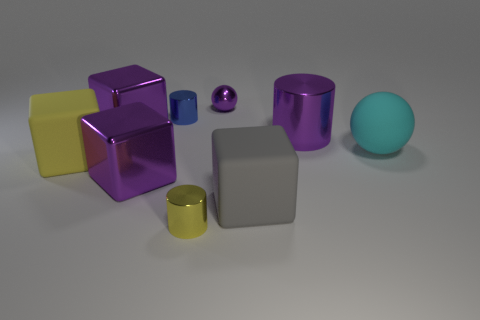Is the material of the ball that is right of the large purple metallic cylinder the same as the yellow object that is on the right side of the big yellow rubber object? No, it is not. The ball to the right of the large purple metallic cylinder appears to have a different texture and finish compared to the yellow object adjacent to the big yellow rubber cube. Specifically, the ball exhibits a matte and slightly translucent surface suggesting a plastic material, while the yellow object has a glossy, solid appearance indicating it might be metallic. 